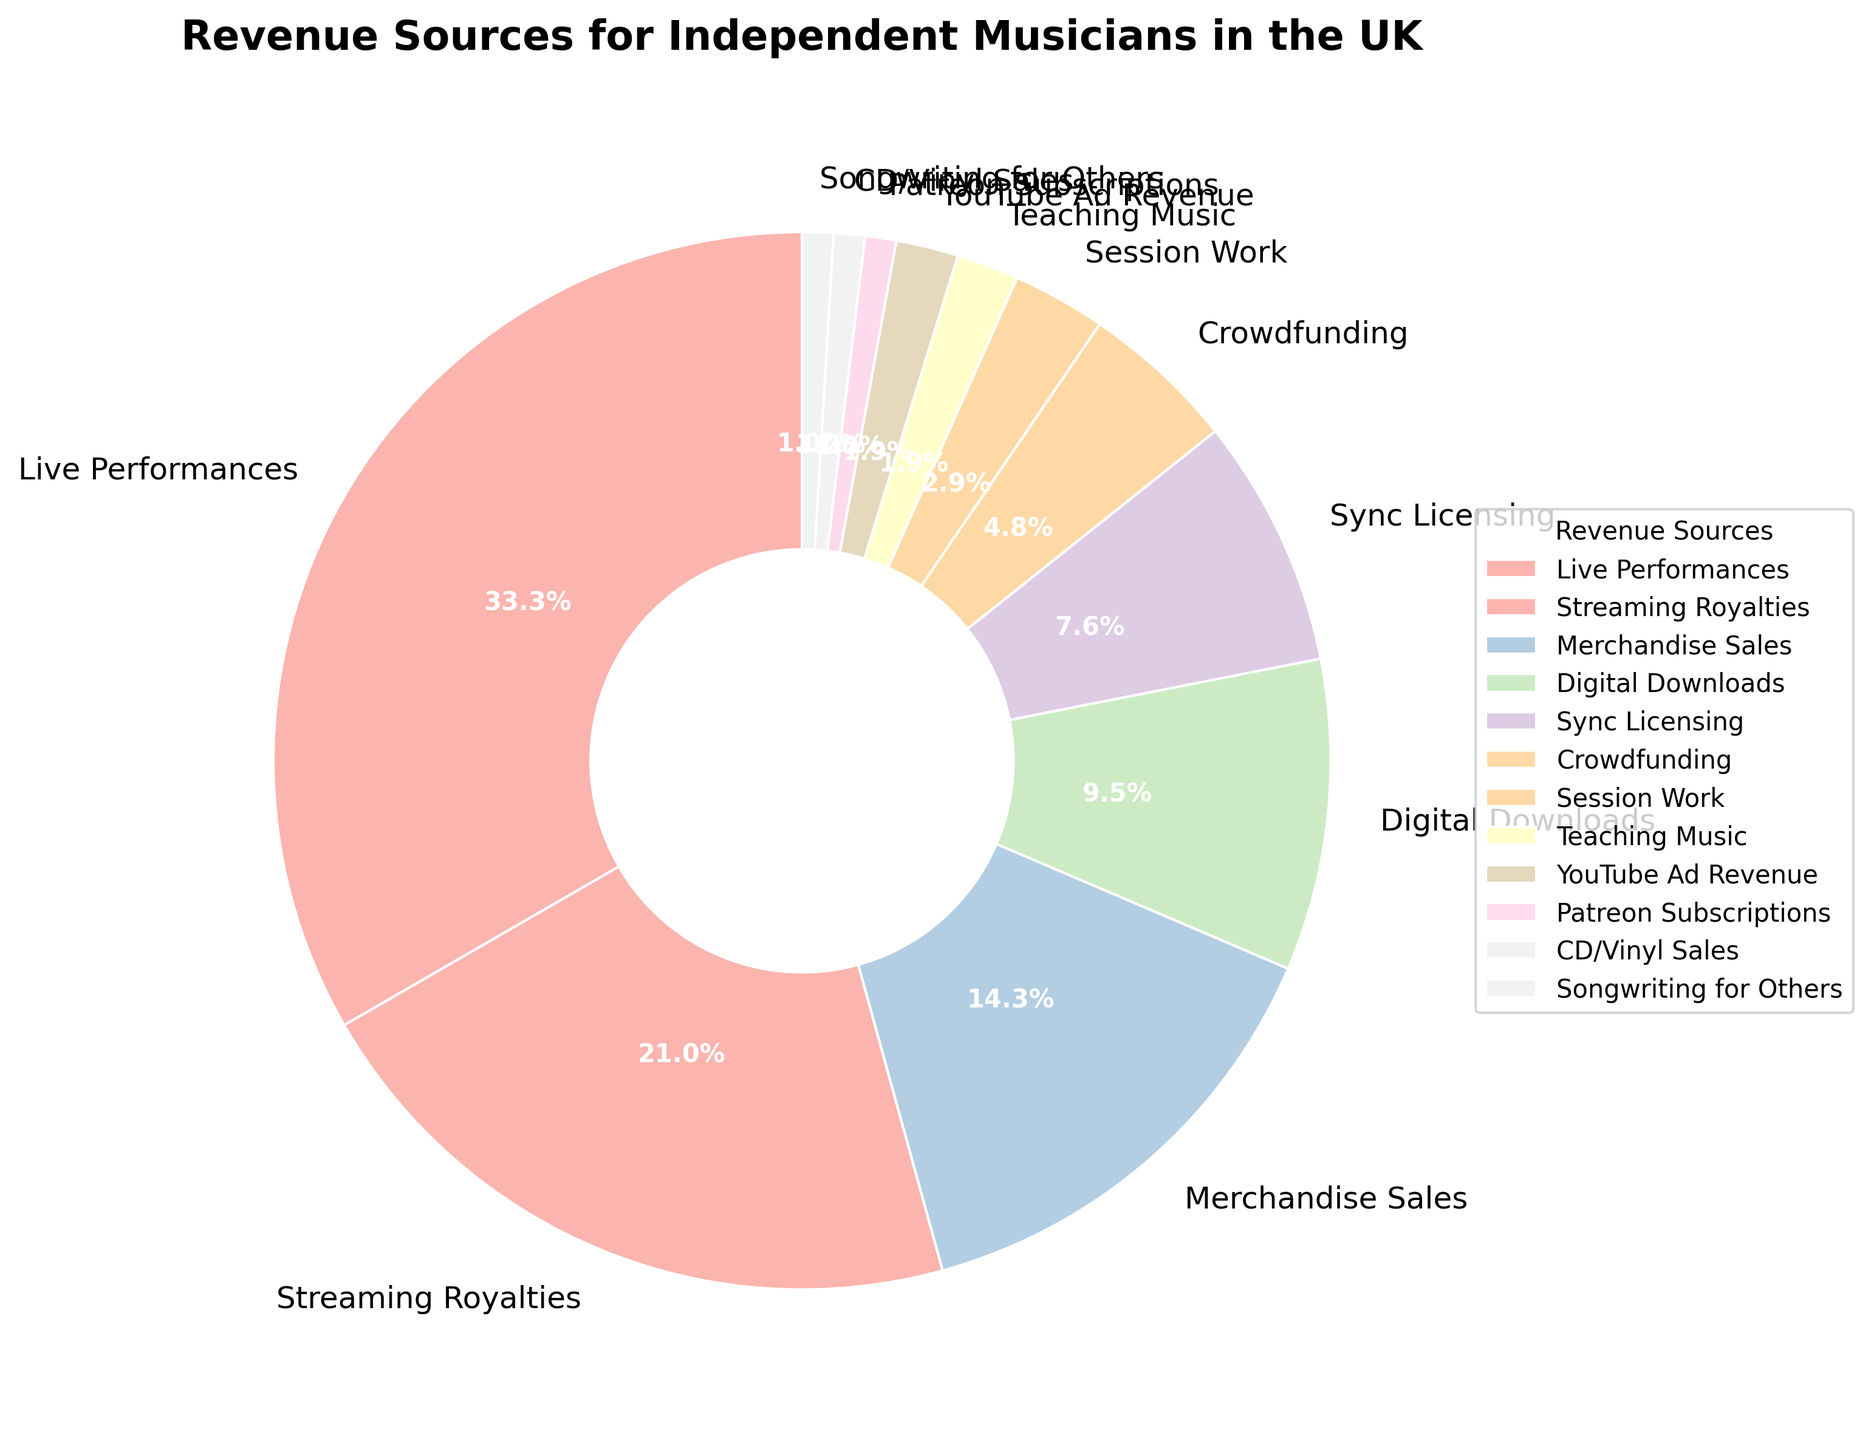What are the top three revenue sources for independent musicians in the UK? The top three percentages in the pie chart are 35% for Live Performances, 22% for Streaming Royalties, and 15% for Merchandise Sales.
Answer: Live Performances, Streaming Royalties, Merchandise Sales Which revenue source contributes the least to the income of independent musicians in the UK? The smallest percentage in the pie chart is 1%, which is attributed to CD/Vinyl Sales, Songwriting for Others, and Patreon Subscriptions.
Answer: CD/Vinyl Sales, Songwriting for Others, Patreon Subscriptions What is the combined percentage of revenue from Digital Downloads and Sync Licensing? The pie chart shows that Digital Downloads contribute 10% and Sync Licensing contributes 8%. Adding these two percentages together gives 10% + 8% = 18%.
Answer: 18% Is the revenue percentage from Teaching Music greater than or less than that from Session Work? The pie chart shows 2% for Teaching Music and 3% for Session Work. Therefore, Teaching Music is less than Session Work.
Answer: Less What is the difference in percentage between the revenue from Live Performances and Streaming Royalties? The percentage for Live Performances is 35% and for Streaming Royalties is 22%. The difference is calculated as 35% - 22% = 13%.
Answer: 13% How much more revenue, in percentage, do Live Performances generate compared to Crowdfunding? Live Performances generate 35% and Crowdfunding generates 5%. The difference is 35% - 5% = 30%.
Answer: 30% Which revenue source has an equal percentage to YouTube Ad Revenue? Both YouTube Ad Revenue and Teaching Music have a percentage of 2% in the pie chart.
Answer: Teaching Music If you combine the revenue percentages from Session Work and Merchandise Sales, how do they compare to the revenue from Live Performances? Session Work contributes 3% and Merchandise Sales 15%, summing to 3% + 15% = 18%. Comparing this with Live Performances' 35%, 18% is less than 35%.
Answer: Less than What is the total percentage for all the revenue sources that contribute 5% or less each? The sources and their respective percentages are Crowdfunding (5%), Session Work (3%), Teaching Music (2%), YouTube Ad Revenue (2%), Patreon Subscriptions (1%), CD/Vinyl Sales (1%), and Songwriting for Others (1%). The total is 5% + 3% + 2% + 2% + 1% + 1% + 1% = 15%.
Answer: 15% Compare the combined revenue percentage from Digital Downloads, Sync Licensing, and Crowdfunding to Live Performances. Which one is larger? Digital Downloads (10%), Sync Licensing (8%), and Crowdfunding (5%) together make 10% + 8% + 5% = 23%. Live Performances is 35%. Therefore, combined is 23% and Live Performances is larger.
Answer: Live Performances 